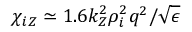<formula> <loc_0><loc_0><loc_500><loc_500>\chi _ { i Z } \simeq 1 . 6 k _ { Z } ^ { 2 } \rho _ { i } ^ { 2 } q ^ { 2 } / \sqrt { \epsilon }</formula> 